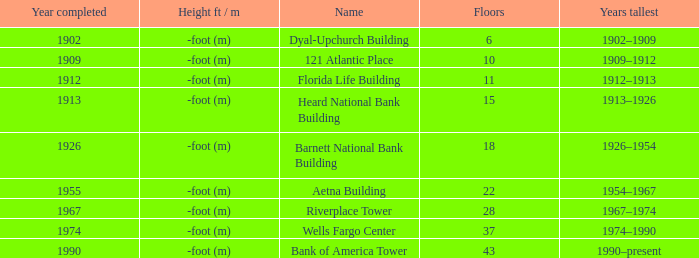What was the name of the building with 10 floors? 121 Atlantic Place. 